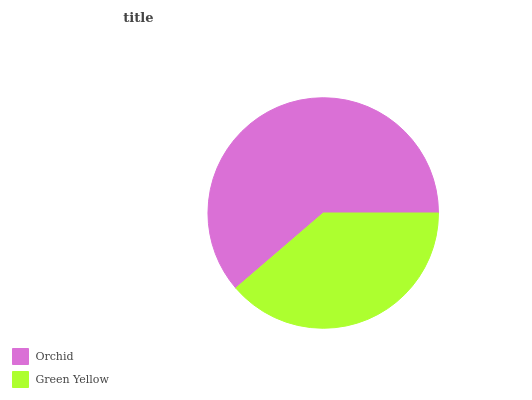Is Green Yellow the minimum?
Answer yes or no. Yes. Is Orchid the maximum?
Answer yes or no. Yes. Is Green Yellow the maximum?
Answer yes or no. No. Is Orchid greater than Green Yellow?
Answer yes or no. Yes. Is Green Yellow less than Orchid?
Answer yes or no. Yes. Is Green Yellow greater than Orchid?
Answer yes or no. No. Is Orchid less than Green Yellow?
Answer yes or no. No. Is Orchid the high median?
Answer yes or no. Yes. Is Green Yellow the low median?
Answer yes or no. Yes. Is Green Yellow the high median?
Answer yes or no. No. Is Orchid the low median?
Answer yes or no. No. 